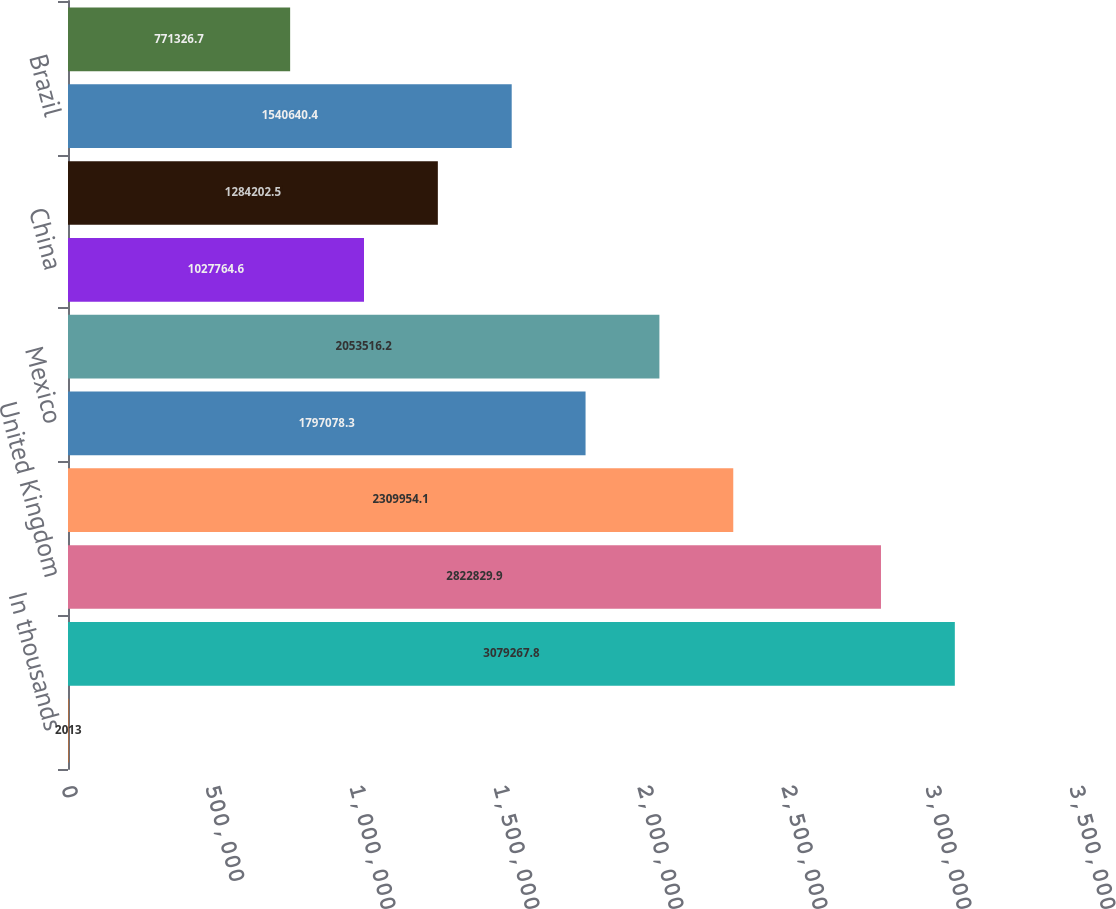Convert chart. <chart><loc_0><loc_0><loc_500><loc_500><bar_chart><fcel>In thousands<fcel>United States<fcel>United Kingdom<fcel>Canada<fcel>Mexico<fcel>Australia<fcel>China<fcel>Germany<fcel>Brazil<fcel>Italy<nl><fcel>2013<fcel>3.07927e+06<fcel>2.82283e+06<fcel>2.30995e+06<fcel>1.79708e+06<fcel>2.05352e+06<fcel>1.02776e+06<fcel>1.2842e+06<fcel>1.54064e+06<fcel>771327<nl></chart> 